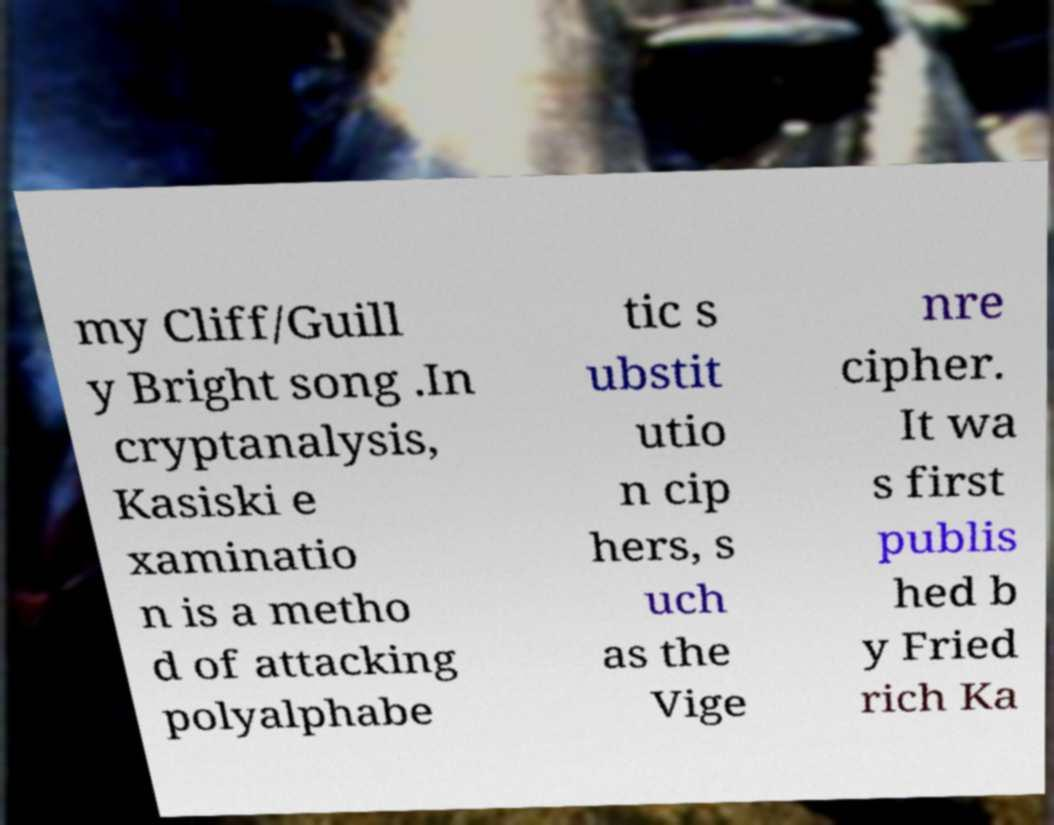Can you accurately transcribe the text from the provided image for me? my Cliff/Guill y Bright song .In cryptanalysis, Kasiski e xaminatio n is a metho d of attacking polyalphabe tic s ubstit utio n cip hers, s uch as the Vige nre cipher. It wa s first publis hed b y Fried rich Ka 